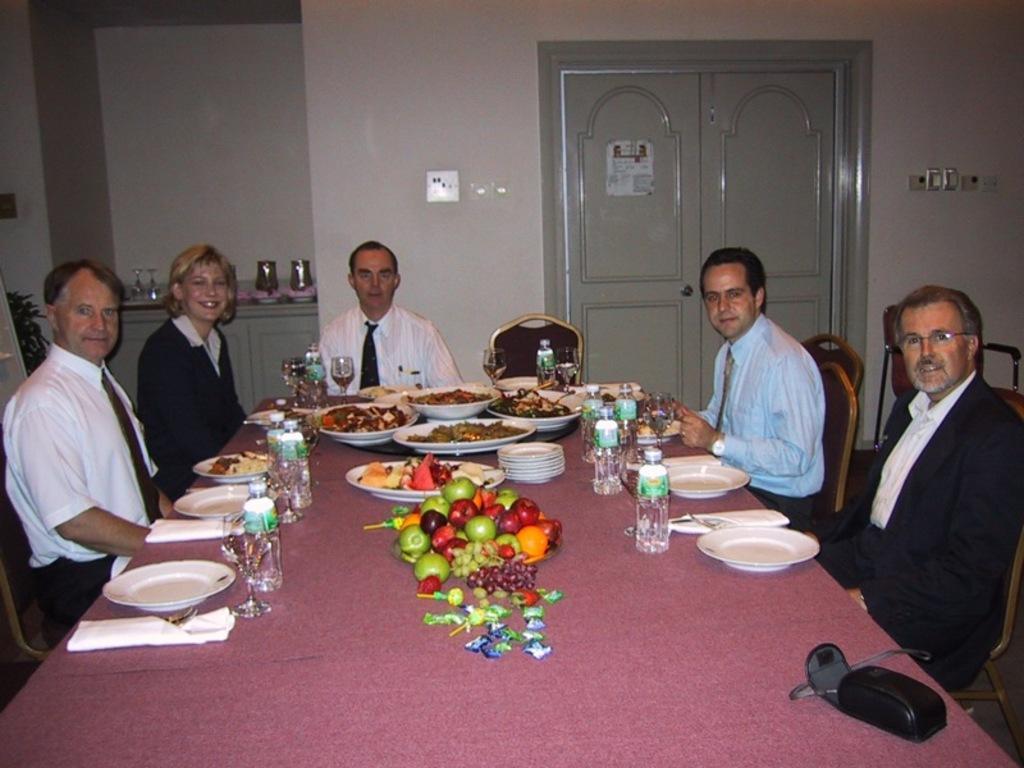How would you summarize this image in a sentence or two? The dining table which is pink in color consists of one two three four five six seven eight plates and many water bottles. And also contain wine glasses. We have vegetables,fruits everything served on this table. Here we can see a camera bag. There are five men sitting around this table. We have six chairs around this table and the man on the left corner is wearing a white color shirt and black color pant, he is watching the camera. Next to him, we find woman who is wearing a blazer black blazer. She is laughing. Next to her, we find a man sitting on the chair is wearing a white color shirt and a tie. On the right most corner, we find a man wearing black blazer and spectacles. Next to him, we find a man sitting on a chair wearing blue color shirt and watch. There are four men and one woman sitting around this table. behind them we find white color wall and grey color door. 